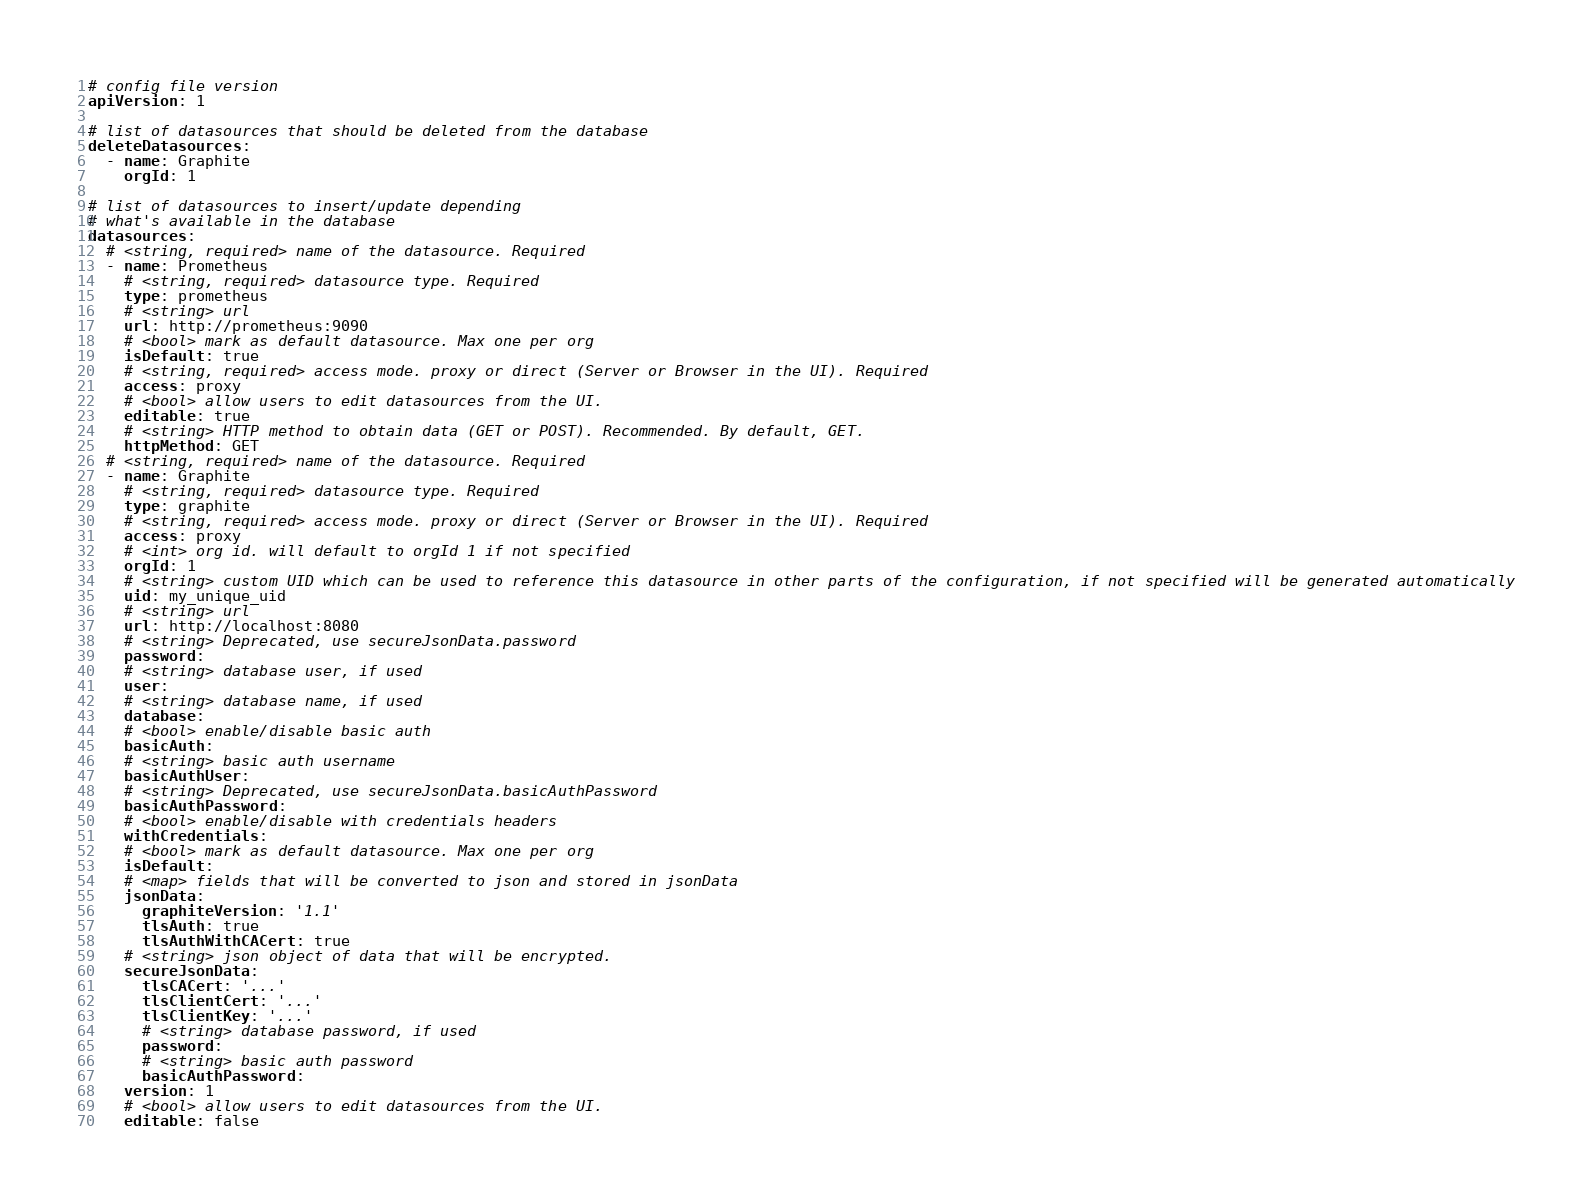Convert code to text. <code><loc_0><loc_0><loc_500><loc_500><_YAML_># config file version
apiVersion: 1

# list of datasources that should be deleted from the database
deleteDatasources:
  - name: Graphite
    orgId: 1

# list of datasources to insert/update depending
# what's available in the database
datasources:
  # <string, required> name of the datasource. Required
  - name: Prometheus
    # <string, required> datasource type. Required
    type: prometheus
    # <string> url
    url: http://prometheus:9090 
    # <bool> mark as default datasource. Max one per org
    isDefault: true
    # <string, required> access mode. proxy or direct (Server or Browser in the UI). Required
    access: proxy
    # <bool> allow users to edit datasources from the UI.
    editable: true
    # <string> HTTP method to obtain data (GET or POST). Recommended. By default, GET.
    httpMethod: GET
  # <string, required> name of the datasource. Required
  - name: Graphite
    # <string, required> datasource type. Required
    type: graphite
    # <string, required> access mode. proxy or direct (Server or Browser in the UI). Required
    access: proxy
    # <int> org id. will default to orgId 1 if not specified
    orgId: 1
    # <string> custom UID which can be used to reference this datasource in other parts of the configuration, if not specified will be generated automatically
    uid: my_unique_uid
    # <string> url
    url: http://localhost:8080
    # <string> Deprecated, use secureJsonData.password
    password:
    # <string> database user, if used
    user:
    # <string> database name, if used
    database:
    # <bool> enable/disable basic auth
    basicAuth:
    # <string> basic auth username
    basicAuthUser:
    # <string> Deprecated, use secureJsonData.basicAuthPassword
    basicAuthPassword:
    # <bool> enable/disable with credentials headers
    withCredentials:
    # <bool> mark as default datasource. Max one per org
    isDefault:
    # <map> fields that will be converted to json and stored in jsonData
    jsonData:
      graphiteVersion: '1.1'
      tlsAuth: true
      tlsAuthWithCACert: true
    # <string> json object of data that will be encrypted.
    secureJsonData:
      tlsCACert: '...'
      tlsClientCert: '...'
      tlsClientKey: '...'
      # <string> database password, if used
      password:
      # <string> basic auth password
      basicAuthPassword:
    version: 1
    # <bool> allow users to edit datasources from the UI.
    editable: false
</code> 